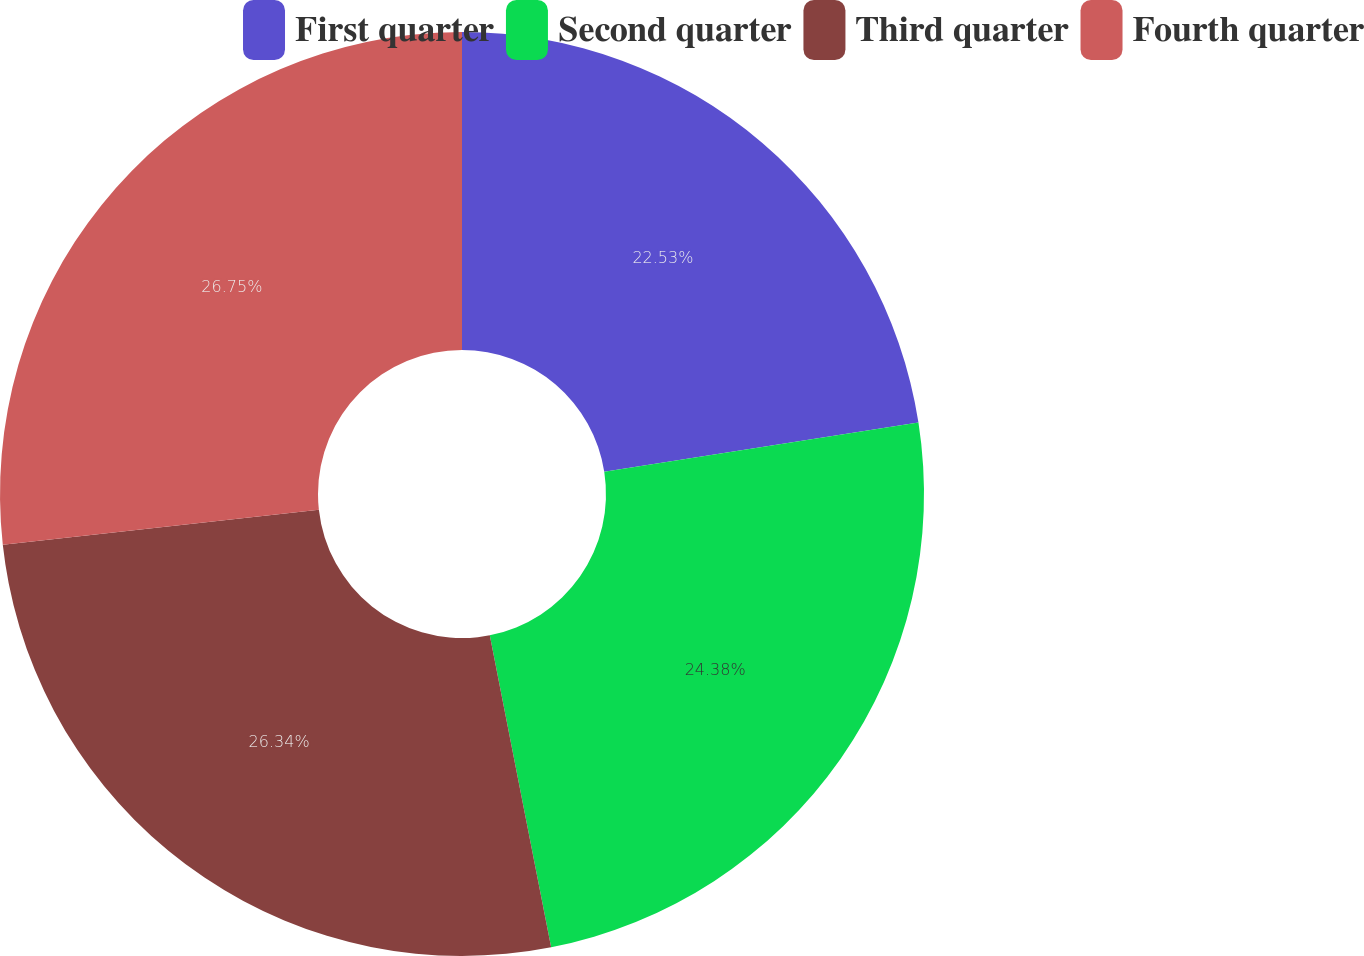Convert chart. <chart><loc_0><loc_0><loc_500><loc_500><pie_chart><fcel>First quarter<fcel>Second quarter<fcel>Third quarter<fcel>Fourth quarter<nl><fcel>22.53%<fcel>24.38%<fcel>26.34%<fcel>26.75%<nl></chart> 